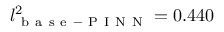<formula> <loc_0><loc_0><loc_500><loc_500>l _ { b a s e - P I N N } ^ { 2 } = 0 . 4 4 0</formula> 